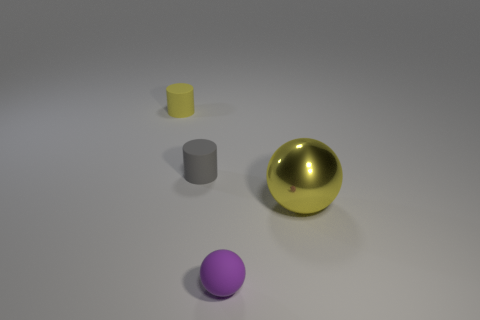Add 1 gray cylinders. How many objects exist? 5 Subtract 0 brown cylinders. How many objects are left? 4 Subtract all gray things. Subtract all large metal spheres. How many objects are left? 2 Add 4 tiny purple balls. How many tiny purple balls are left? 5 Add 1 big blue matte cylinders. How many big blue matte cylinders exist? 1 